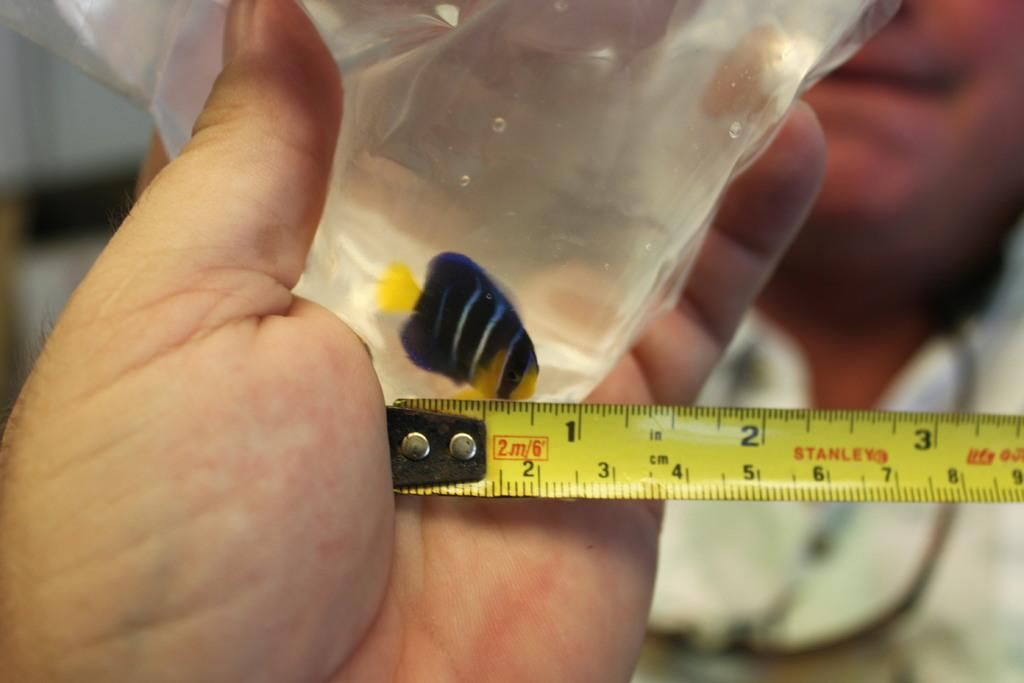<image>
Provide a brief description of the given image. The fish in the bag is about one inch in length. 